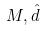<formula> <loc_0><loc_0><loc_500><loc_500>M , \hat { d }</formula> 